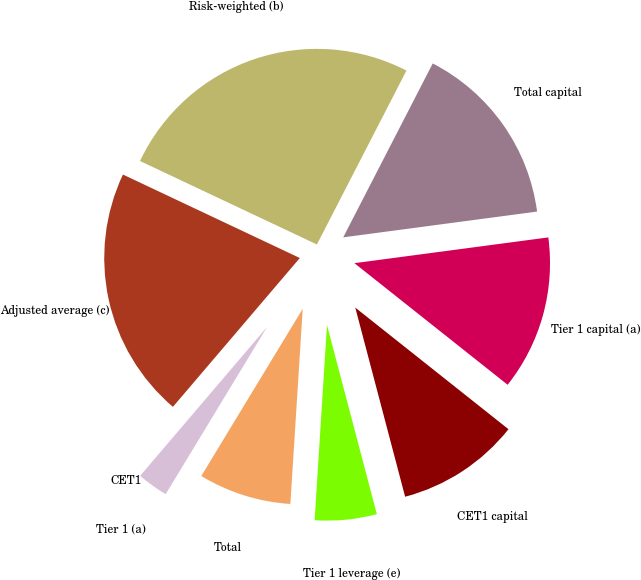<chart> <loc_0><loc_0><loc_500><loc_500><pie_chart><fcel>CET1 capital<fcel>Tier 1 capital (a)<fcel>Total capital<fcel>Risk-weighted (b)<fcel>Adjusted average (c)<fcel>CET1<fcel>Tier 1 (a)<fcel>Total<fcel>Tier 1 leverage (e)<nl><fcel>10.22%<fcel>12.78%<fcel>15.33%<fcel>25.55%<fcel>20.78%<fcel>0.0%<fcel>2.56%<fcel>7.67%<fcel>5.11%<nl></chart> 